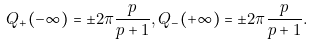<formula> <loc_0><loc_0><loc_500><loc_500>Q _ { + } ( - \infty ) = \pm 2 \pi \frac { p } { p + 1 } , Q _ { - } ( + \infty ) = \pm 2 \pi \frac { p } { p + 1 } .</formula> 